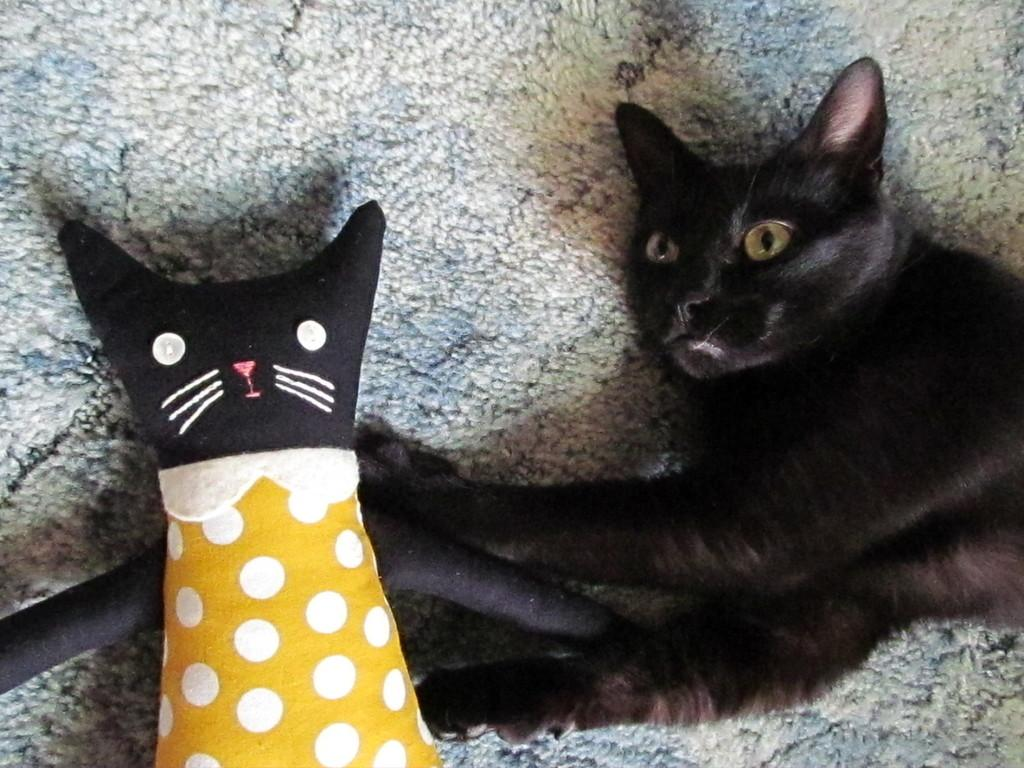What type of animal can be seen lying on the mat in the image? There is a cat lying on the mat on the right side of the image. What object is on the left side of the image? There is a cushion on the left side of the image. How many lizards can be seen swimming in the water in the image? There are no lizards or water present in the image; it features a cat lying on a mat and a cushion on the left side. 